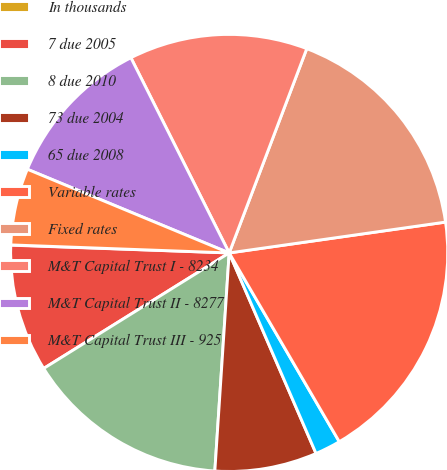Convert chart. <chart><loc_0><loc_0><loc_500><loc_500><pie_chart><fcel>In thousands<fcel>7 due 2005<fcel>8 due 2010<fcel>73 due 2004<fcel>65 due 2008<fcel>Variable rates<fcel>Fixed rates<fcel>M&T Capital Trust I - 8234<fcel>M&T Capital Trust II - 8277<fcel>M&T Capital Trust III - 925<nl><fcel>0.02%<fcel>9.43%<fcel>15.09%<fcel>7.55%<fcel>1.9%<fcel>18.85%<fcel>16.97%<fcel>13.2%<fcel>11.32%<fcel>5.67%<nl></chart> 